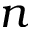Convert formula to latex. <formula><loc_0><loc_0><loc_500><loc_500>n</formula> 